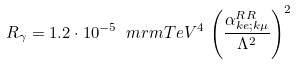<formula> <loc_0><loc_0><loc_500><loc_500>R _ { \gamma } = 1 . 2 \cdot 1 0 ^ { - 5 } \, \ m r m { T e V } ^ { 4 } \, \left ( \frac { \alpha _ { k e ; k \mu } ^ { R R } } { \Lambda ^ { 2 } } \right ) ^ { 2 } \,</formula> 